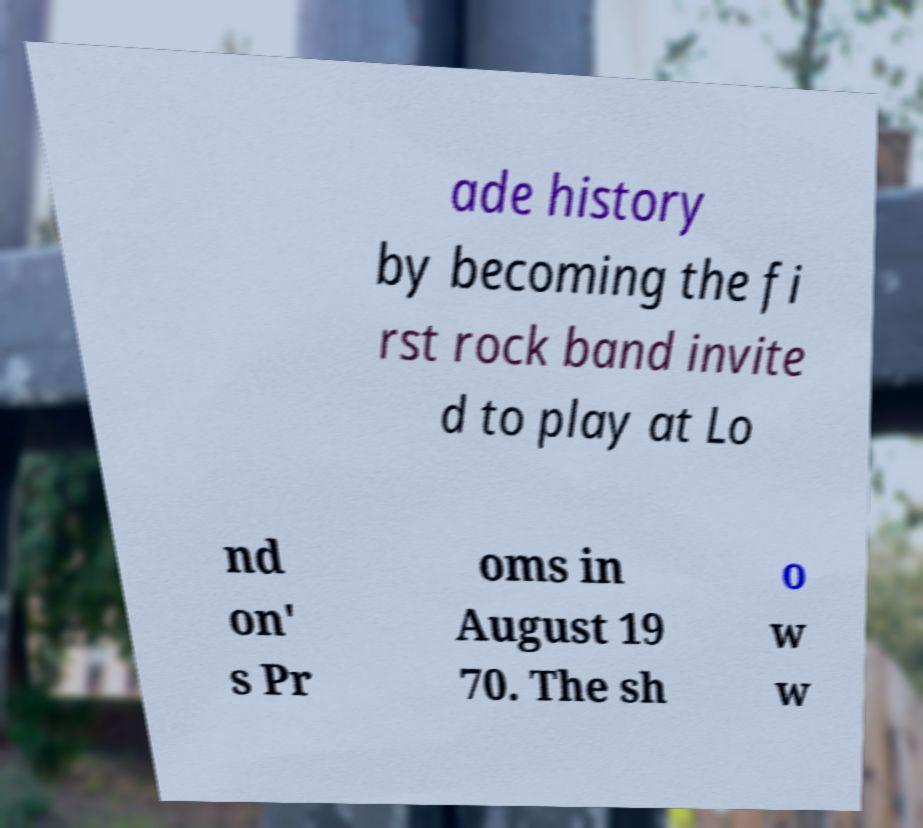Could you extract and type out the text from this image? ade history by becoming the fi rst rock band invite d to play at Lo nd on' s Pr oms in August 19 70. The sh o w w 